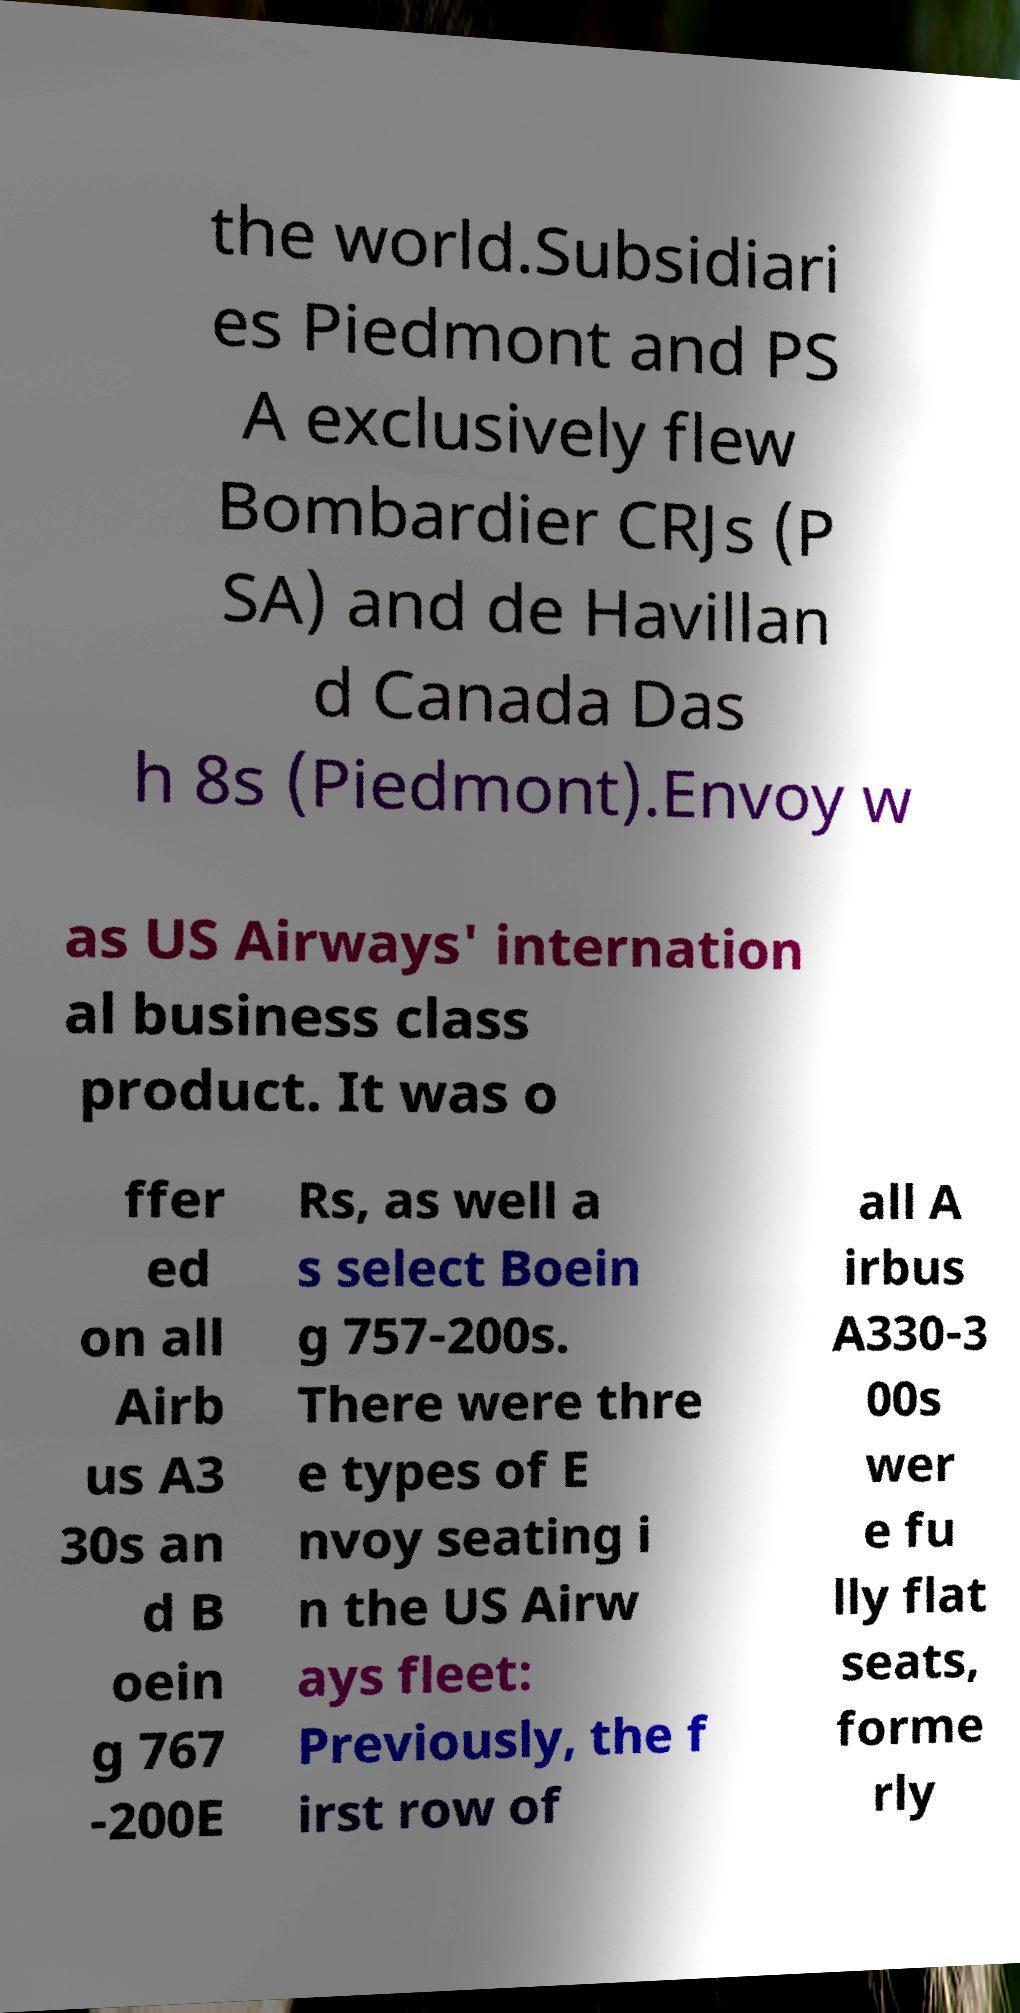Please identify and transcribe the text found in this image. the world.Subsidiari es Piedmont and PS A exclusively flew Bombardier CRJs (P SA) and de Havillan d Canada Das h 8s (Piedmont).Envoy w as US Airways' internation al business class product. It was o ffer ed on all Airb us A3 30s an d B oein g 767 -200E Rs, as well a s select Boein g 757-200s. There were thre e types of E nvoy seating i n the US Airw ays fleet: Previously, the f irst row of all A irbus A330-3 00s wer e fu lly flat seats, forme rly 